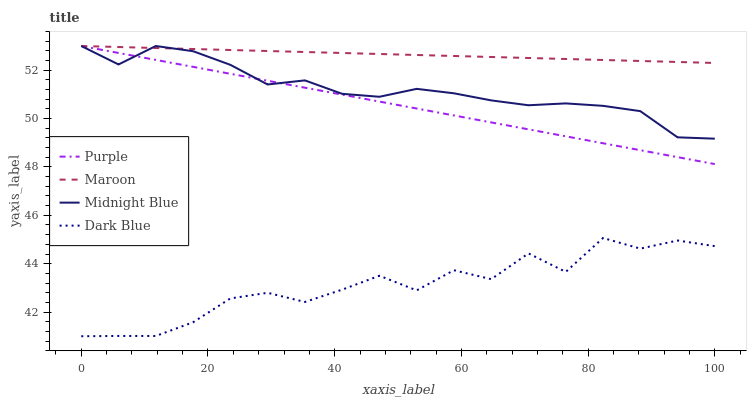Does Dark Blue have the minimum area under the curve?
Answer yes or no. Yes. Does Maroon have the maximum area under the curve?
Answer yes or no. Yes. Does Midnight Blue have the minimum area under the curve?
Answer yes or no. No. Does Midnight Blue have the maximum area under the curve?
Answer yes or no. No. Is Maroon the smoothest?
Answer yes or no. Yes. Is Dark Blue the roughest?
Answer yes or no. Yes. Is Midnight Blue the smoothest?
Answer yes or no. No. Is Midnight Blue the roughest?
Answer yes or no. No. Does Dark Blue have the lowest value?
Answer yes or no. Yes. Does Midnight Blue have the lowest value?
Answer yes or no. No. Does Maroon have the highest value?
Answer yes or no. Yes. Does Dark Blue have the highest value?
Answer yes or no. No. Is Dark Blue less than Maroon?
Answer yes or no. Yes. Is Purple greater than Dark Blue?
Answer yes or no. Yes. Does Purple intersect Maroon?
Answer yes or no. Yes. Is Purple less than Maroon?
Answer yes or no. No. Is Purple greater than Maroon?
Answer yes or no. No. Does Dark Blue intersect Maroon?
Answer yes or no. No. 